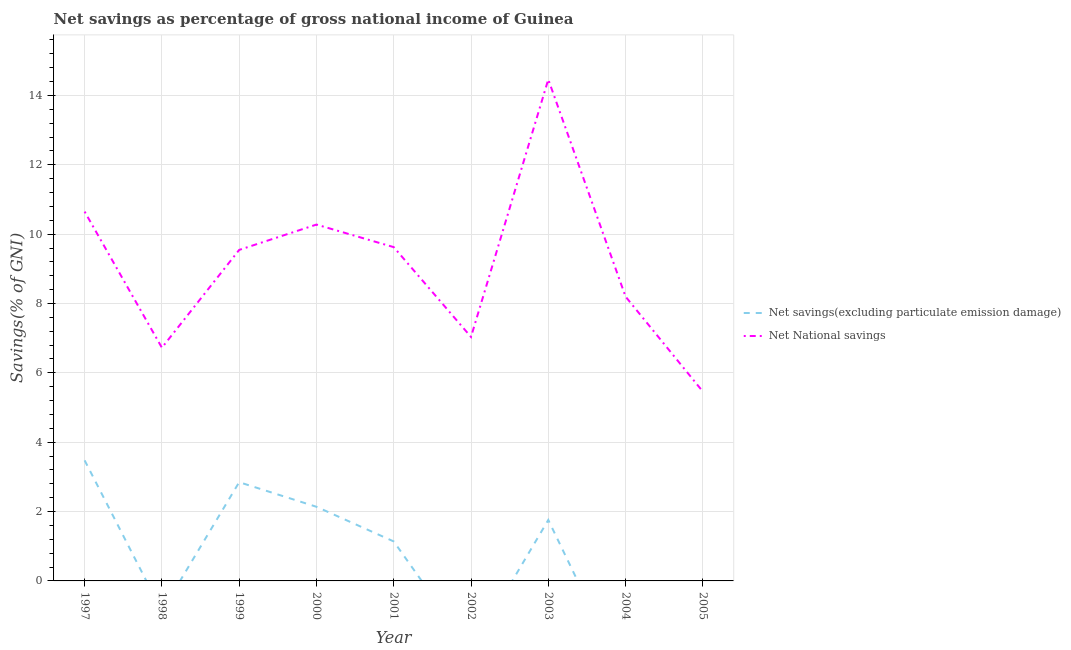How many different coloured lines are there?
Make the answer very short. 2. Across all years, what is the maximum net savings(excluding particulate emission damage)?
Ensure brevity in your answer.  3.48. Across all years, what is the minimum net national savings?
Make the answer very short. 5.46. What is the total net savings(excluding particulate emission damage) in the graph?
Your answer should be compact. 11.36. What is the difference between the net national savings in 2002 and that in 2005?
Your response must be concise. 1.58. What is the difference between the net savings(excluding particulate emission damage) in 2003 and the net national savings in 2001?
Offer a very short reply. -7.87. What is the average net savings(excluding particulate emission damage) per year?
Keep it short and to the point. 1.26. In the year 1999, what is the difference between the net savings(excluding particulate emission damage) and net national savings?
Offer a terse response. -6.7. In how many years, is the net national savings greater than 9.2 %?
Your answer should be compact. 5. What is the ratio of the net national savings in 1997 to that in 1998?
Your answer should be compact. 1.58. What is the difference between the highest and the second highest net savings(excluding particulate emission damage)?
Ensure brevity in your answer.  0.63. What is the difference between the highest and the lowest net savings(excluding particulate emission damage)?
Provide a short and direct response. 3.48. In how many years, is the net savings(excluding particulate emission damage) greater than the average net savings(excluding particulate emission damage) taken over all years?
Your answer should be compact. 4. Is the sum of the net national savings in 2004 and 2005 greater than the maximum net savings(excluding particulate emission damage) across all years?
Offer a terse response. Yes. Does the net national savings monotonically increase over the years?
Offer a terse response. No. How many years are there in the graph?
Provide a succinct answer. 9. Are the values on the major ticks of Y-axis written in scientific E-notation?
Keep it short and to the point. No. Does the graph contain grids?
Keep it short and to the point. Yes. How many legend labels are there?
Your answer should be compact. 2. How are the legend labels stacked?
Your response must be concise. Vertical. What is the title of the graph?
Offer a terse response. Net savings as percentage of gross national income of Guinea. What is the label or title of the X-axis?
Your response must be concise. Year. What is the label or title of the Y-axis?
Keep it short and to the point. Savings(% of GNI). What is the Savings(% of GNI) in Net savings(excluding particulate emission damage) in 1997?
Offer a terse response. 3.48. What is the Savings(% of GNI) in Net National savings in 1997?
Keep it short and to the point. 10.65. What is the Savings(% of GNI) in Net savings(excluding particulate emission damage) in 1998?
Keep it short and to the point. 0. What is the Savings(% of GNI) of Net National savings in 1998?
Ensure brevity in your answer.  6.73. What is the Savings(% of GNI) in Net savings(excluding particulate emission damage) in 1999?
Your response must be concise. 2.85. What is the Savings(% of GNI) of Net National savings in 1999?
Provide a short and direct response. 9.55. What is the Savings(% of GNI) of Net savings(excluding particulate emission damage) in 2000?
Give a very brief answer. 2.14. What is the Savings(% of GNI) of Net National savings in 2000?
Ensure brevity in your answer.  10.28. What is the Savings(% of GNI) in Net savings(excluding particulate emission damage) in 2001?
Give a very brief answer. 1.14. What is the Savings(% of GNI) in Net National savings in 2001?
Make the answer very short. 9.63. What is the Savings(% of GNI) in Net National savings in 2002?
Keep it short and to the point. 7.04. What is the Savings(% of GNI) in Net savings(excluding particulate emission damage) in 2003?
Your response must be concise. 1.76. What is the Savings(% of GNI) in Net National savings in 2003?
Your response must be concise. 14.46. What is the Savings(% of GNI) in Net National savings in 2004?
Ensure brevity in your answer.  8.2. What is the Savings(% of GNI) in Net National savings in 2005?
Make the answer very short. 5.46. Across all years, what is the maximum Savings(% of GNI) of Net savings(excluding particulate emission damage)?
Make the answer very short. 3.48. Across all years, what is the maximum Savings(% of GNI) of Net National savings?
Your response must be concise. 14.46. Across all years, what is the minimum Savings(% of GNI) of Net National savings?
Your response must be concise. 5.46. What is the total Savings(% of GNI) in Net savings(excluding particulate emission damage) in the graph?
Provide a succinct answer. 11.36. What is the total Savings(% of GNI) in Net National savings in the graph?
Offer a very short reply. 81.98. What is the difference between the Savings(% of GNI) in Net National savings in 1997 and that in 1998?
Your response must be concise. 3.92. What is the difference between the Savings(% of GNI) of Net savings(excluding particulate emission damage) in 1997 and that in 1999?
Make the answer very short. 0.63. What is the difference between the Savings(% of GNI) in Net National savings in 1997 and that in 1999?
Provide a short and direct response. 1.1. What is the difference between the Savings(% of GNI) in Net savings(excluding particulate emission damage) in 1997 and that in 2000?
Make the answer very short. 1.34. What is the difference between the Savings(% of GNI) in Net National savings in 1997 and that in 2000?
Provide a short and direct response. 0.37. What is the difference between the Savings(% of GNI) in Net savings(excluding particulate emission damage) in 1997 and that in 2001?
Provide a short and direct response. 2.34. What is the difference between the Savings(% of GNI) of Net National savings in 1997 and that in 2001?
Offer a terse response. 1.02. What is the difference between the Savings(% of GNI) of Net National savings in 1997 and that in 2002?
Ensure brevity in your answer.  3.61. What is the difference between the Savings(% of GNI) of Net savings(excluding particulate emission damage) in 1997 and that in 2003?
Provide a succinct answer. 1.72. What is the difference between the Savings(% of GNI) of Net National savings in 1997 and that in 2003?
Keep it short and to the point. -3.81. What is the difference between the Savings(% of GNI) of Net National savings in 1997 and that in 2004?
Your answer should be very brief. 2.45. What is the difference between the Savings(% of GNI) in Net National savings in 1997 and that in 2005?
Keep it short and to the point. 5.19. What is the difference between the Savings(% of GNI) of Net National savings in 1998 and that in 1999?
Provide a succinct answer. -2.82. What is the difference between the Savings(% of GNI) of Net National savings in 1998 and that in 2000?
Keep it short and to the point. -3.55. What is the difference between the Savings(% of GNI) in Net National savings in 1998 and that in 2001?
Offer a very short reply. -2.9. What is the difference between the Savings(% of GNI) of Net National savings in 1998 and that in 2002?
Keep it short and to the point. -0.31. What is the difference between the Savings(% of GNI) in Net National savings in 1998 and that in 2003?
Offer a very short reply. -7.74. What is the difference between the Savings(% of GNI) in Net National savings in 1998 and that in 2004?
Give a very brief answer. -1.47. What is the difference between the Savings(% of GNI) of Net National savings in 1998 and that in 2005?
Provide a short and direct response. 1.26. What is the difference between the Savings(% of GNI) of Net savings(excluding particulate emission damage) in 1999 and that in 2000?
Give a very brief answer. 0.71. What is the difference between the Savings(% of GNI) in Net National savings in 1999 and that in 2000?
Offer a terse response. -0.73. What is the difference between the Savings(% of GNI) in Net savings(excluding particulate emission damage) in 1999 and that in 2001?
Your answer should be compact. 1.71. What is the difference between the Savings(% of GNI) of Net National savings in 1999 and that in 2001?
Your answer should be compact. -0.08. What is the difference between the Savings(% of GNI) of Net National savings in 1999 and that in 2002?
Give a very brief answer. 2.51. What is the difference between the Savings(% of GNI) of Net savings(excluding particulate emission damage) in 1999 and that in 2003?
Make the answer very short. 1.09. What is the difference between the Savings(% of GNI) in Net National savings in 1999 and that in 2003?
Provide a succinct answer. -4.92. What is the difference between the Savings(% of GNI) of Net National savings in 1999 and that in 2004?
Give a very brief answer. 1.35. What is the difference between the Savings(% of GNI) in Net National savings in 1999 and that in 2005?
Ensure brevity in your answer.  4.08. What is the difference between the Savings(% of GNI) in Net savings(excluding particulate emission damage) in 2000 and that in 2001?
Give a very brief answer. 1. What is the difference between the Savings(% of GNI) in Net National savings in 2000 and that in 2001?
Offer a very short reply. 0.65. What is the difference between the Savings(% of GNI) in Net National savings in 2000 and that in 2002?
Provide a short and direct response. 3.24. What is the difference between the Savings(% of GNI) of Net savings(excluding particulate emission damage) in 2000 and that in 2003?
Your answer should be compact. 0.38. What is the difference between the Savings(% of GNI) in Net National savings in 2000 and that in 2003?
Your answer should be very brief. -4.18. What is the difference between the Savings(% of GNI) of Net National savings in 2000 and that in 2004?
Keep it short and to the point. 2.08. What is the difference between the Savings(% of GNI) of Net National savings in 2000 and that in 2005?
Your answer should be compact. 4.82. What is the difference between the Savings(% of GNI) of Net National savings in 2001 and that in 2002?
Offer a very short reply. 2.59. What is the difference between the Savings(% of GNI) of Net savings(excluding particulate emission damage) in 2001 and that in 2003?
Provide a short and direct response. -0.62. What is the difference between the Savings(% of GNI) in Net National savings in 2001 and that in 2003?
Your response must be concise. -4.84. What is the difference between the Savings(% of GNI) in Net National savings in 2001 and that in 2004?
Ensure brevity in your answer.  1.43. What is the difference between the Savings(% of GNI) in Net National savings in 2001 and that in 2005?
Offer a terse response. 4.17. What is the difference between the Savings(% of GNI) in Net National savings in 2002 and that in 2003?
Offer a terse response. -7.43. What is the difference between the Savings(% of GNI) of Net National savings in 2002 and that in 2004?
Your response must be concise. -1.16. What is the difference between the Savings(% of GNI) in Net National savings in 2002 and that in 2005?
Your response must be concise. 1.58. What is the difference between the Savings(% of GNI) of Net National savings in 2003 and that in 2004?
Provide a short and direct response. 6.26. What is the difference between the Savings(% of GNI) in Net National savings in 2003 and that in 2005?
Your answer should be compact. 9. What is the difference between the Savings(% of GNI) of Net National savings in 2004 and that in 2005?
Your answer should be compact. 2.74. What is the difference between the Savings(% of GNI) in Net savings(excluding particulate emission damage) in 1997 and the Savings(% of GNI) in Net National savings in 1998?
Your answer should be compact. -3.25. What is the difference between the Savings(% of GNI) of Net savings(excluding particulate emission damage) in 1997 and the Savings(% of GNI) of Net National savings in 1999?
Give a very brief answer. -6.07. What is the difference between the Savings(% of GNI) of Net savings(excluding particulate emission damage) in 1997 and the Savings(% of GNI) of Net National savings in 2000?
Make the answer very short. -6.8. What is the difference between the Savings(% of GNI) in Net savings(excluding particulate emission damage) in 1997 and the Savings(% of GNI) in Net National savings in 2001?
Make the answer very short. -6.15. What is the difference between the Savings(% of GNI) in Net savings(excluding particulate emission damage) in 1997 and the Savings(% of GNI) in Net National savings in 2002?
Your response must be concise. -3.56. What is the difference between the Savings(% of GNI) in Net savings(excluding particulate emission damage) in 1997 and the Savings(% of GNI) in Net National savings in 2003?
Your answer should be compact. -10.98. What is the difference between the Savings(% of GNI) of Net savings(excluding particulate emission damage) in 1997 and the Savings(% of GNI) of Net National savings in 2004?
Your response must be concise. -4.72. What is the difference between the Savings(% of GNI) in Net savings(excluding particulate emission damage) in 1997 and the Savings(% of GNI) in Net National savings in 2005?
Your response must be concise. -1.98. What is the difference between the Savings(% of GNI) in Net savings(excluding particulate emission damage) in 1999 and the Savings(% of GNI) in Net National savings in 2000?
Offer a terse response. -7.43. What is the difference between the Savings(% of GNI) of Net savings(excluding particulate emission damage) in 1999 and the Savings(% of GNI) of Net National savings in 2001?
Provide a short and direct response. -6.78. What is the difference between the Savings(% of GNI) in Net savings(excluding particulate emission damage) in 1999 and the Savings(% of GNI) in Net National savings in 2002?
Keep it short and to the point. -4.19. What is the difference between the Savings(% of GNI) in Net savings(excluding particulate emission damage) in 1999 and the Savings(% of GNI) in Net National savings in 2003?
Make the answer very short. -11.61. What is the difference between the Savings(% of GNI) of Net savings(excluding particulate emission damage) in 1999 and the Savings(% of GNI) of Net National savings in 2004?
Your response must be concise. -5.35. What is the difference between the Savings(% of GNI) of Net savings(excluding particulate emission damage) in 1999 and the Savings(% of GNI) of Net National savings in 2005?
Provide a short and direct response. -2.61. What is the difference between the Savings(% of GNI) in Net savings(excluding particulate emission damage) in 2000 and the Savings(% of GNI) in Net National savings in 2001?
Ensure brevity in your answer.  -7.49. What is the difference between the Savings(% of GNI) in Net savings(excluding particulate emission damage) in 2000 and the Savings(% of GNI) in Net National savings in 2002?
Your answer should be compact. -4.9. What is the difference between the Savings(% of GNI) in Net savings(excluding particulate emission damage) in 2000 and the Savings(% of GNI) in Net National savings in 2003?
Keep it short and to the point. -12.32. What is the difference between the Savings(% of GNI) of Net savings(excluding particulate emission damage) in 2000 and the Savings(% of GNI) of Net National savings in 2004?
Keep it short and to the point. -6.06. What is the difference between the Savings(% of GNI) of Net savings(excluding particulate emission damage) in 2000 and the Savings(% of GNI) of Net National savings in 2005?
Give a very brief answer. -3.32. What is the difference between the Savings(% of GNI) in Net savings(excluding particulate emission damage) in 2001 and the Savings(% of GNI) in Net National savings in 2002?
Your answer should be very brief. -5.9. What is the difference between the Savings(% of GNI) of Net savings(excluding particulate emission damage) in 2001 and the Savings(% of GNI) of Net National savings in 2003?
Provide a short and direct response. -13.32. What is the difference between the Savings(% of GNI) in Net savings(excluding particulate emission damage) in 2001 and the Savings(% of GNI) in Net National savings in 2004?
Give a very brief answer. -7.06. What is the difference between the Savings(% of GNI) of Net savings(excluding particulate emission damage) in 2001 and the Savings(% of GNI) of Net National savings in 2005?
Provide a succinct answer. -4.32. What is the difference between the Savings(% of GNI) in Net savings(excluding particulate emission damage) in 2003 and the Savings(% of GNI) in Net National savings in 2004?
Your answer should be very brief. -6.44. What is the difference between the Savings(% of GNI) of Net savings(excluding particulate emission damage) in 2003 and the Savings(% of GNI) of Net National savings in 2005?
Offer a very short reply. -3.7. What is the average Savings(% of GNI) in Net savings(excluding particulate emission damage) per year?
Give a very brief answer. 1.26. What is the average Savings(% of GNI) in Net National savings per year?
Ensure brevity in your answer.  9.11. In the year 1997, what is the difference between the Savings(% of GNI) of Net savings(excluding particulate emission damage) and Savings(% of GNI) of Net National savings?
Your answer should be compact. -7.17. In the year 1999, what is the difference between the Savings(% of GNI) of Net savings(excluding particulate emission damage) and Savings(% of GNI) of Net National savings?
Your answer should be very brief. -6.7. In the year 2000, what is the difference between the Savings(% of GNI) in Net savings(excluding particulate emission damage) and Savings(% of GNI) in Net National savings?
Provide a short and direct response. -8.14. In the year 2001, what is the difference between the Savings(% of GNI) in Net savings(excluding particulate emission damage) and Savings(% of GNI) in Net National savings?
Keep it short and to the point. -8.49. In the year 2003, what is the difference between the Savings(% of GNI) of Net savings(excluding particulate emission damage) and Savings(% of GNI) of Net National savings?
Offer a terse response. -12.7. What is the ratio of the Savings(% of GNI) of Net National savings in 1997 to that in 1998?
Make the answer very short. 1.58. What is the ratio of the Savings(% of GNI) of Net savings(excluding particulate emission damage) in 1997 to that in 1999?
Give a very brief answer. 1.22. What is the ratio of the Savings(% of GNI) in Net National savings in 1997 to that in 1999?
Your answer should be compact. 1.12. What is the ratio of the Savings(% of GNI) of Net savings(excluding particulate emission damage) in 1997 to that in 2000?
Your answer should be very brief. 1.63. What is the ratio of the Savings(% of GNI) of Net National savings in 1997 to that in 2000?
Ensure brevity in your answer.  1.04. What is the ratio of the Savings(% of GNI) of Net savings(excluding particulate emission damage) in 1997 to that in 2001?
Keep it short and to the point. 3.05. What is the ratio of the Savings(% of GNI) of Net National savings in 1997 to that in 2001?
Give a very brief answer. 1.11. What is the ratio of the Savings(% of GNI) in Net National savings in 1997 to that in 2002?
Provide a short and direct response. 1.51. What is the ratio of the Savings(% of GNI) of Net savings(excluding particulate emission damage) in 1997 to that in 2003?
Make the answer very short. 1.98. What is the ratio of the Savings(% of GNI) in Net National savings in 1997 to that in 2003?
Provide a short and direct response. 0.74. What is the ratio of the Savings(% of GNI) of Net National savings in 1997 to that in 2004?
Keep it short and to the point. 1.3. What is the ratio of the Savings(% of GNI) of Net National savings in 1997 to that in 2005?
Your answer should be very brief. 1.95. What is the ratio of the Savings(% of GNI) in Net National savings in 1998 to that in 1999?
Keep it short and to the point. 0.7. What is the ratio of the Savings(% of GNI) of Net National savings in 1998 to that in 2000?
Provide a short and direct response. 0.65. What is the ratio of the Savings(% of GNI) in Net National savings in 1998 to that in 2001?
Keep it short and to the point. 0.7. What is the ratio of the Savings(% of GNI) in Net National savings in 1998 to that in 2002?
Your answer should be compact. 0.96. What is the ratio of the Savings(% of GNI) in Net National savings in 1998 to that in 2003?
Make the answer very short. 0.47. What is the ratio of the Savings(% of GNI) of Net National savings in 1998 to that in 2004?
Your answer should be very brief. 0.82. What is the ratio of the Savings(% of GNI) in Net National savings in 1998 to that in 2005?
Provide a succinct answer. 1.23. What is the ratio of the Savings(% of GNI) of Net savings(excluding particulate emission damage) in 1999 to that in 2000?
Give a very brief answer. 1.33. What is the ratio of the Savings(% of GNI) of Net National savings in 1999 to that in 2000?
Your answer should be compact. 0.93. What is the ratio of the Savings(% of GNI) in Net savings(excluding particulate emission damage) in 1999 to that in 2001?
Offer a very short reply. 2.5. What is the ratio of the Savings(% of GNI) of Net National savings in 1999 to that in 2001?
Your answer should be compact. 0.99. What is the ratio of the Savings(% of GNI) in Net National savings in 1999 to that in 2002?
Your answer should be compact. 1.36. What is the ratio of the Savings(% of GNI) in Net savings(excluding particulate emission damage) in 1999 to that in 2003?
Provide a short and direct response. 1.62. What is the ratio of the Savings(% of GNI) of Net National savings in 1999 to that in 2003?
Your answer should be compact. 0.66. What is the ratio of the Savings(% of GNI) in Net National savings in 1999 to that in 2004?
Give a very brief answer. 1.16. What is the ratio of the Savings(% of GNI) of Net National savings in 1999 to that in 2005?
Your answer should be very brief. 1.75. What is the ratio of the Savings(% of GNI) of Net savings(excluding particulate emission damage) in 2000 to that in 2001?
Your answer should be compact. 1.88. What is the ratio of the Savings(% of GNI) in Net National savings in 2000 to that in 2001?
Ensure brevity in your answer.  1.07. What is the ratio of the Savings(% of GNI) of Net National savings in 2000 to that in 2002?
Give a very brief answer. 1.46. What is the ratio of the Savings(% of GNI) in Net savings(excluding particulate emission damage) in 2000 to that in 2003?
Give a very brief answer. 1.22. What is the ratio of the Savings(% of GNI) in Net National savings in 2000 to that in 2003?
Offer a terse response. 0.71. What is the ratio of the Savings(% of GNI) of Net National savings in 2000 to that in 2004?
Offer a terse response. 1.25. What is the ratio of the Savings(% of GNI) of Net National savings in 2000 to that in 2005?
Provide a succinct answer. 1.88. What is the ratio of the Savings(% of GNI) in Net National savings in 2001 to that in 2002?
Give a very brief answer. 1.37. What is the ratio of the Savings(% of GNI) of Net savings(excluding particulate emission damage) in 2001 to that in 2003?
Provide a succinct answer. 0.65. What is the ratio of the Savings(% of GNI) in Net National savings in 2001 to that in 2003?
Your response must be concise. 0.67. What is the ratio of the Savings(% of GNI) in Net National savings in 2001 to that in 2004?
Keep it short and to the point. 1.17. What is the ratio of the Savings(% of GNI) of Net National savings in 2001 to that in 2005?
Your answer should be very brief. 1.76. What is the ratio of the Savings(% of GNI) of Net National savings in 2002 to that in 2003?
Your response must be concise. 0.49. What is the ratio of the Savings(% of GNI) in Net National savings in 2002 to that in 2004?
Your response must be concise. 0.86. What is the ratio of the Savings(% of GNI) of Net National savings in 2002 to that in 2005?
Your answer should be compact. 1.29. What is the ratio of the Savings(% of GNI) of Net National savings in 2003 to that in 2004?
Your answer should be very brief. 1.76. What is the ratio of the Savings(% of GNI) in Net National savings in 2003 to that in 2005?
Your answer should be compact. 2.65. What is the ratio of the Savings(% of GNI) of Net National savings in 2004 to that in 2005?
Provide a short and direct response. 1.5. What is the difference between the highest and the second highest Savings(% of GNI) of Net savings(excluding particulate emission damage)?
Your answer should be very brief. 0.63. What is the difference between the highest and the second highest Savings(% of GNI) of Net National savings?
Your response must be concise. 3.81. What is the difference between the highest and the lowest Savings(% of GNI) in Net savings(excluding particulate emission damage)?
Your answer should be compact. 3.48. What is the difference between the highest and the lowest Savings(% of GNI) in Net National savings?
Make the answer very short. 9. 